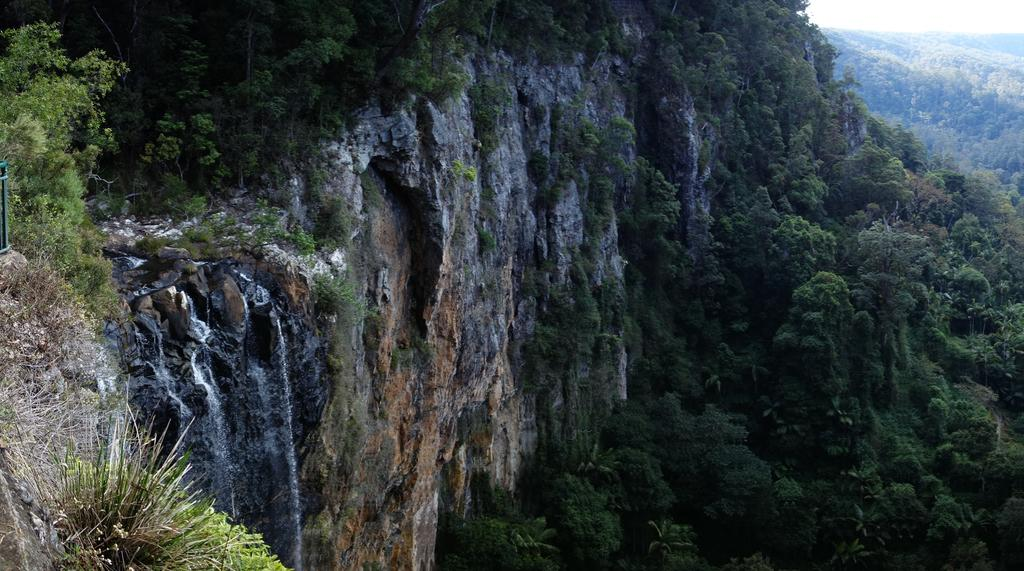What type of natural landform can be seen in the image? There are hills in the image. What body of water is visible in the image? There is water visible in the image. What type of geological feature can be seen in the image? There are rocks in the image. What type of vegetation is present in the image? There are plants and trees in the image. What type of bucket is being used to collect love in the image? There is no bucket or mention of love present in the image. 